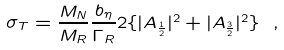<formula> <loc_0><loc_0><loc_500><loc_500>\sigma _ { T } = \frac { M _ { N } } { M _ { R } } \frac { b _ { \eta } } { \Gamma _ { R } } 2 \{ | A _ { \frac { 1 } { 2 } } | ^ { 2 } + | A _ { \frac { 3 } { 2 } } | ^ { 2 } \} \ ,</formula> 